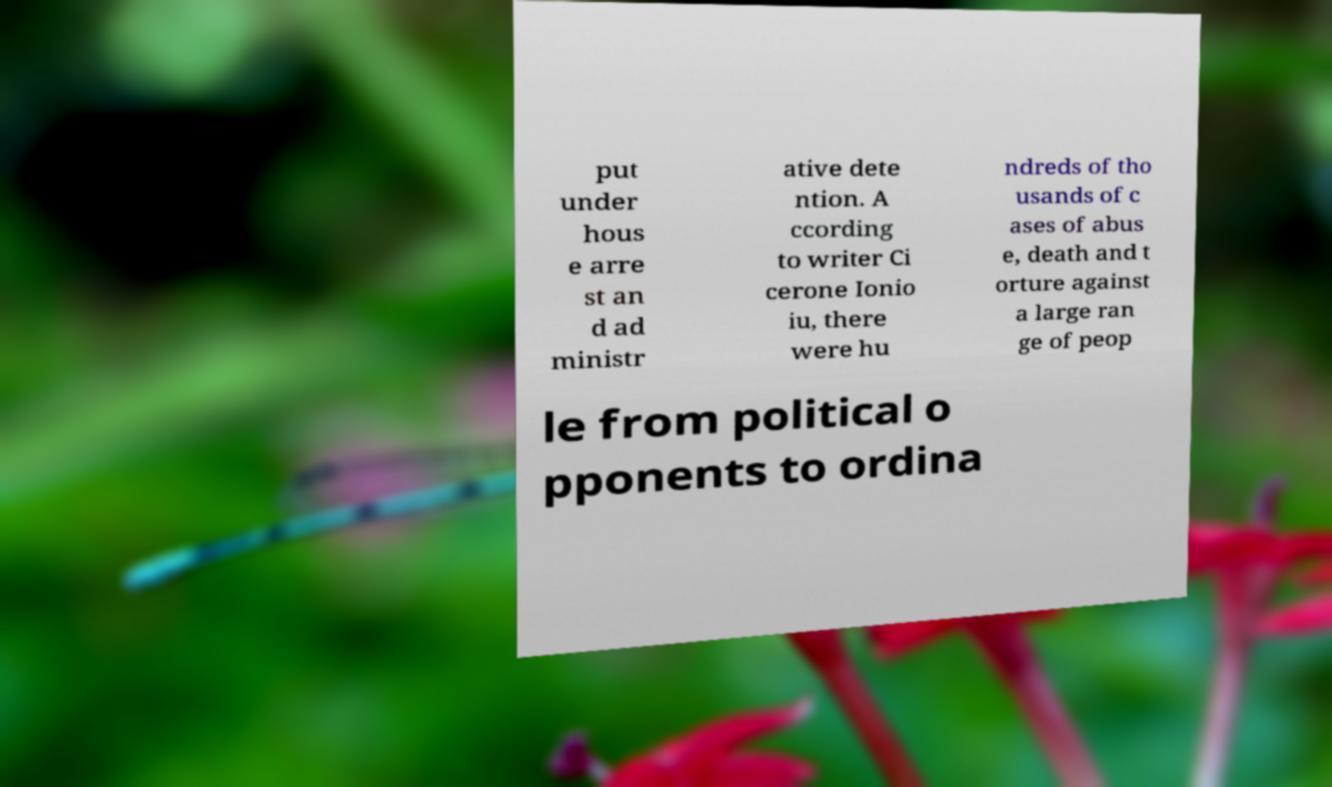Can you accurately transcribe the text from the provided image for me? put under hous e arre st an d ad ministr ative dete ntion. A ccording to writer Ci cerone Ionio iu, there were hu ndreds of tho usands of c ases of abus e, death and t orture against a large ran ge of peop le from political o pponents to ordina 